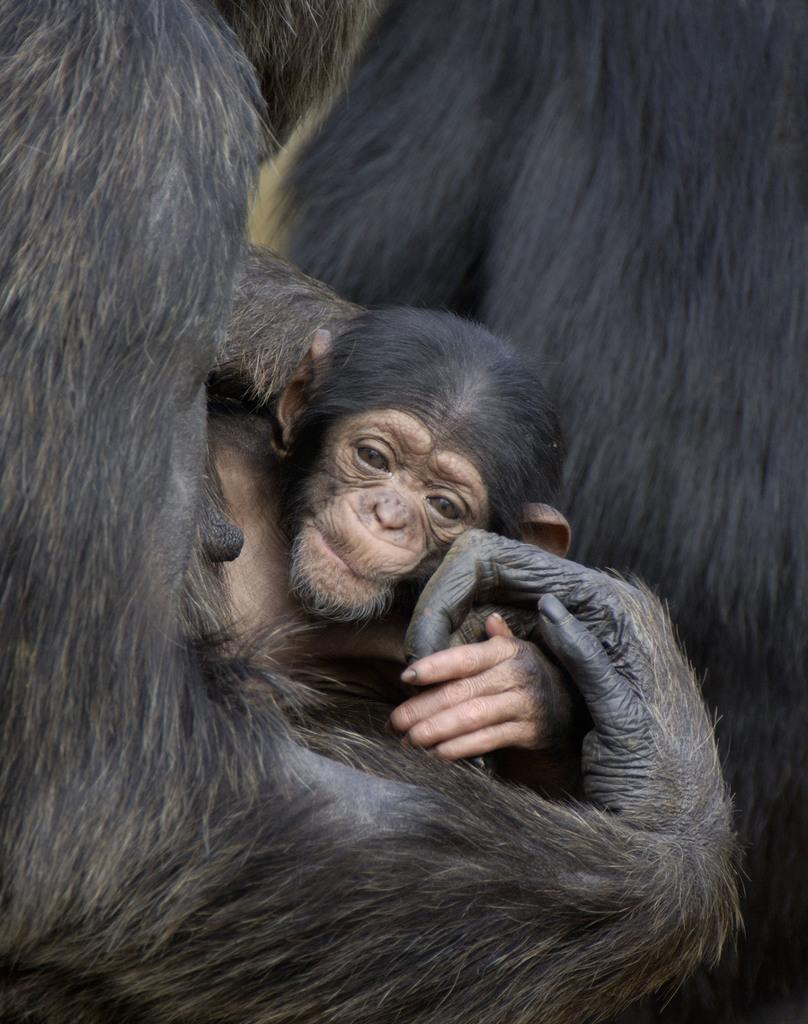How many monkeys are present in the image? There are two monkeys in the image. What is the color of the monkeys? The monkeys are black in color. What advice does the dad give to the monkeys in the image? There is no dad present in the image, and therefore no advice can be given. 